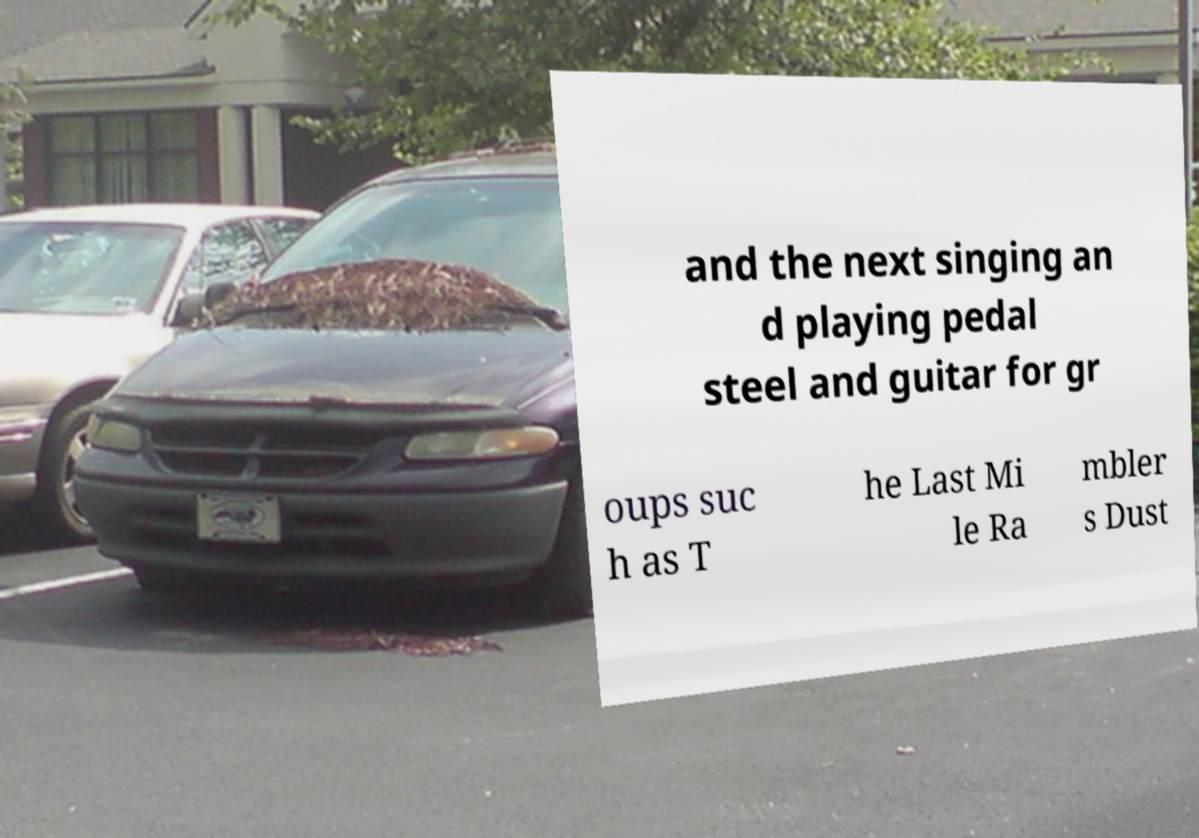I need the written content from this picture converted into text. Can you do that? and the next singing an d playing pedal steel and guitar for gr oups suc h as T he Last Mi le Ra mbler s Dust 